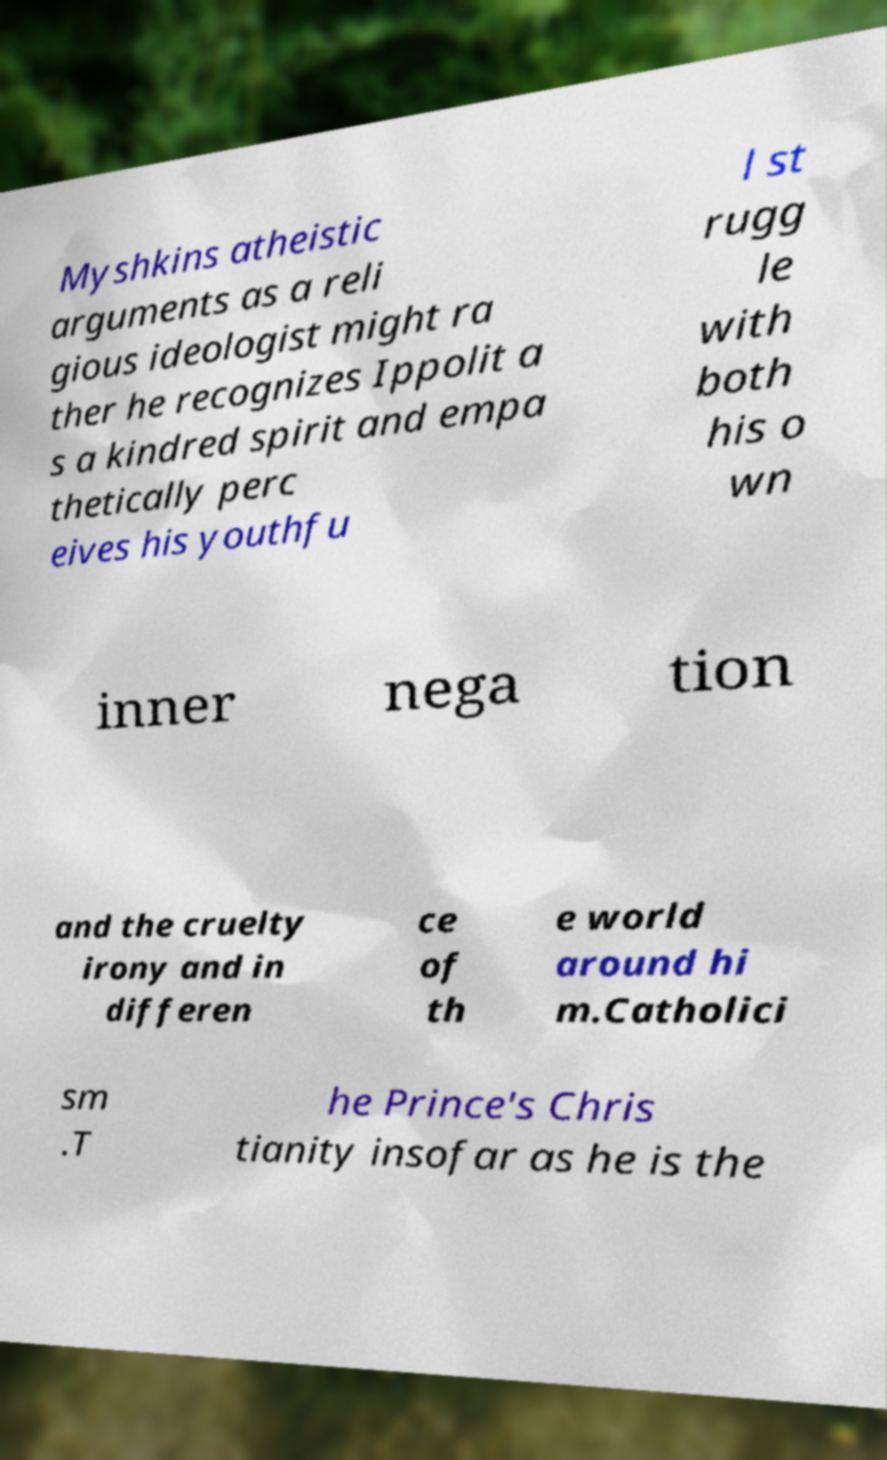Can you accurately transcribe the text from the provided image for me? Myshkins atheistic arguments as a reli gious ideologist might ra ther he recognizes Ippolit a s a kindred spirit and empa thetically perc eives his youthfu l st rugg le with both his o wn inner nega tion and the cruelty irony and in differen ce of th e world around hi m.Catholici sm .T he Prince's Chris tianity insofar as he is the 